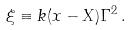Convert formula to latex. <formula><loc_0><loc_0><loc_500><loc_500>\xi \equiv k ( x - X ) \Gamma ^ { 2 } \, .</formula> 